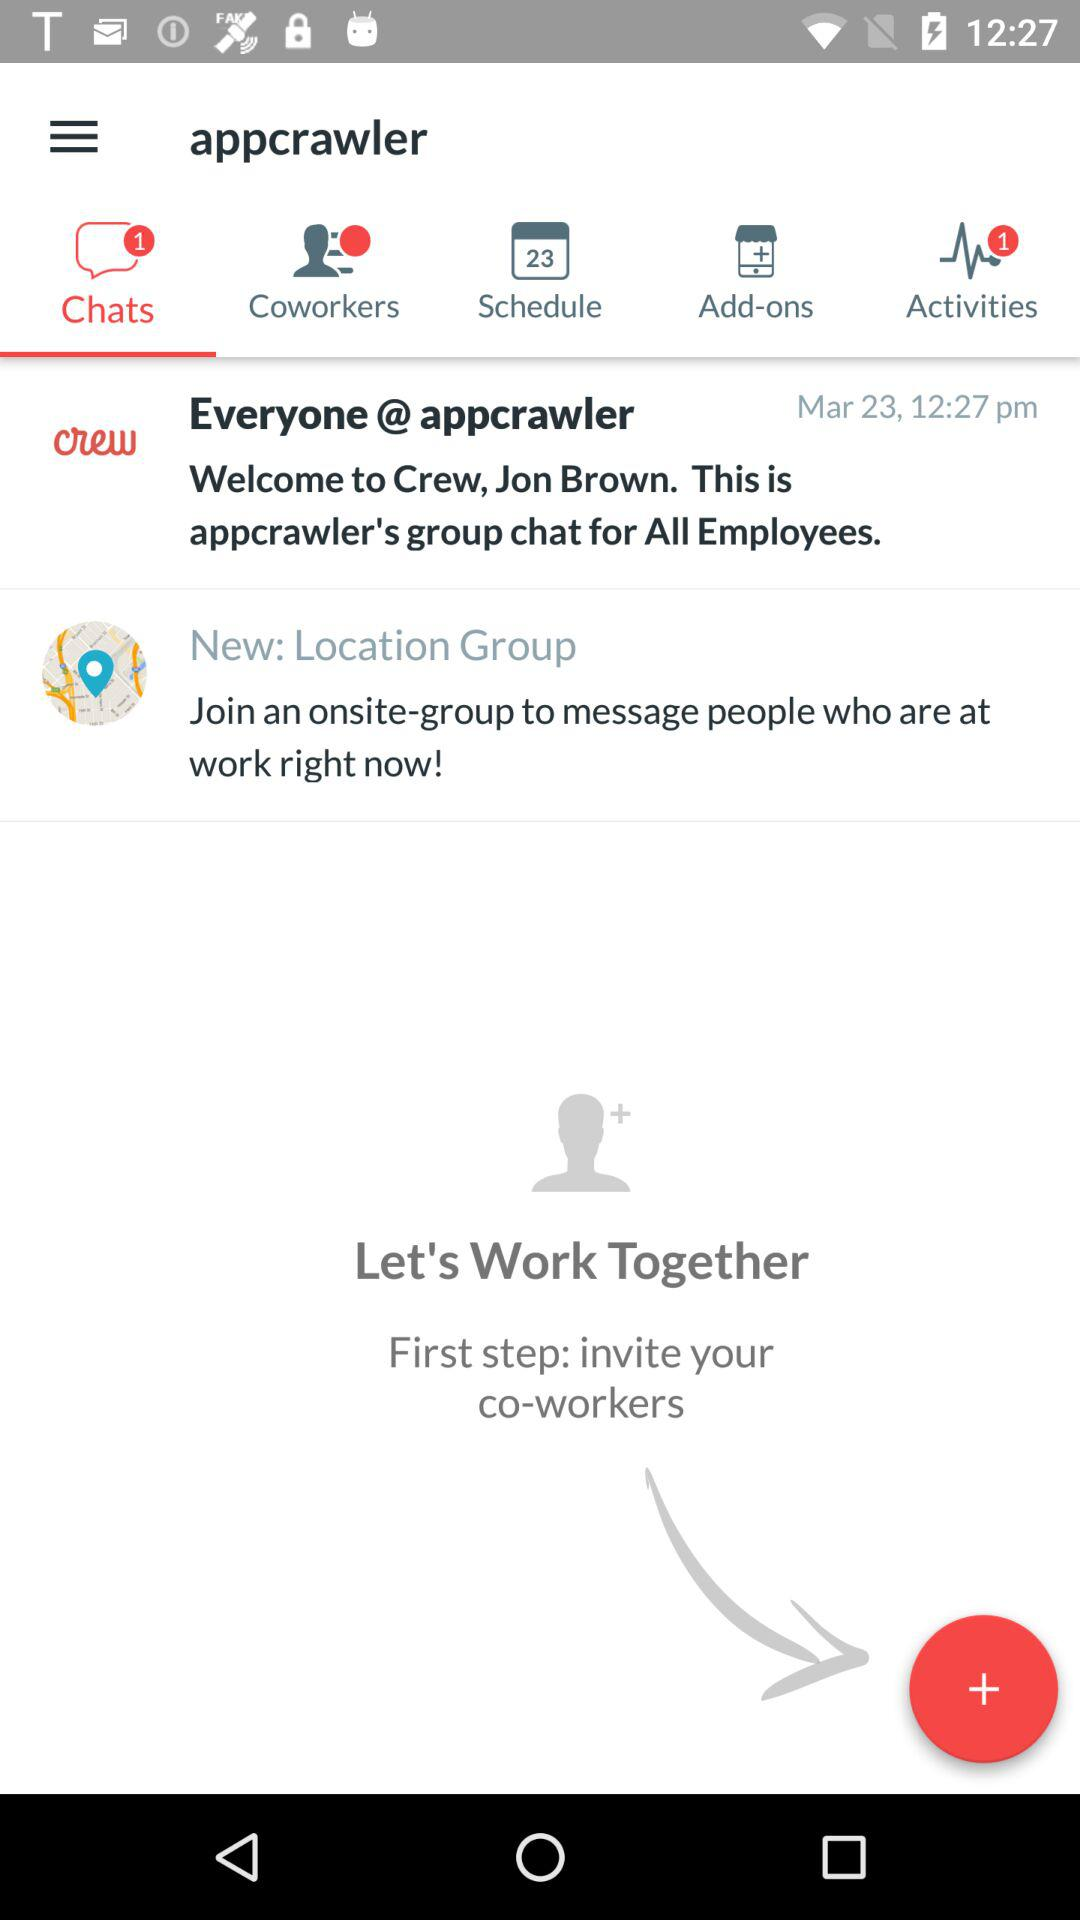How many notifications are pending on coworkers?
When the provided information is insufficient, respond with <no answer>. <no answer> 